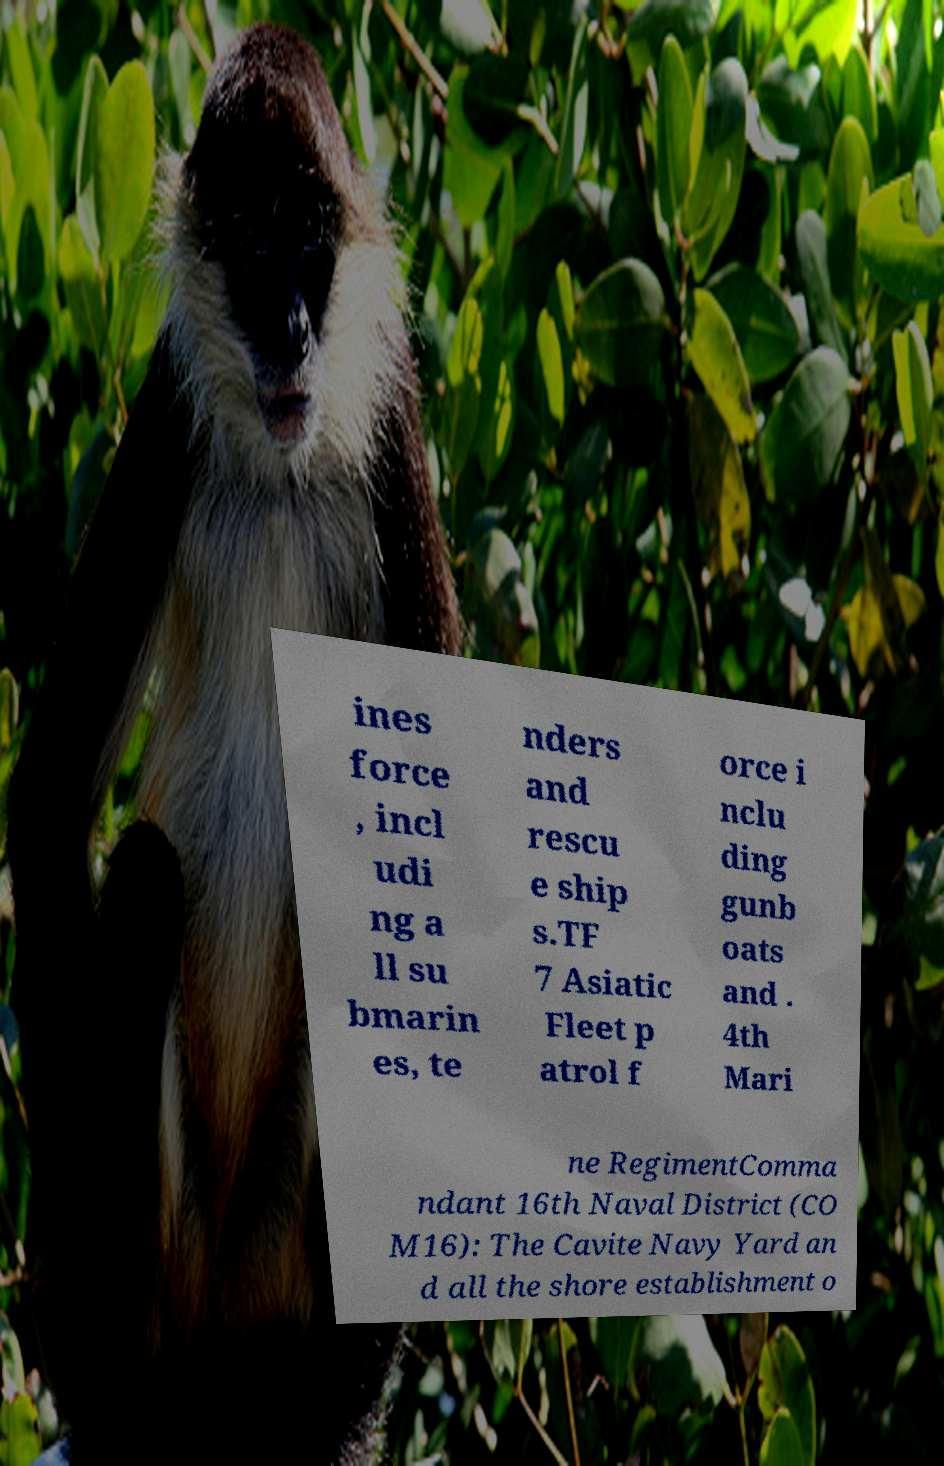Please read and relay the text visible in this image. What does it say? ines force , incl udi ng a ll su bmarin es, te nders and rescu e ship s.TF 7 Asiatic Fleet p atrol f orce i nclu ding gunb oats and . 4th Mari ne RegimentComma ndant 16th Naval District (CO M16): The Cavite Navy Yard an d all the shore establishment o 